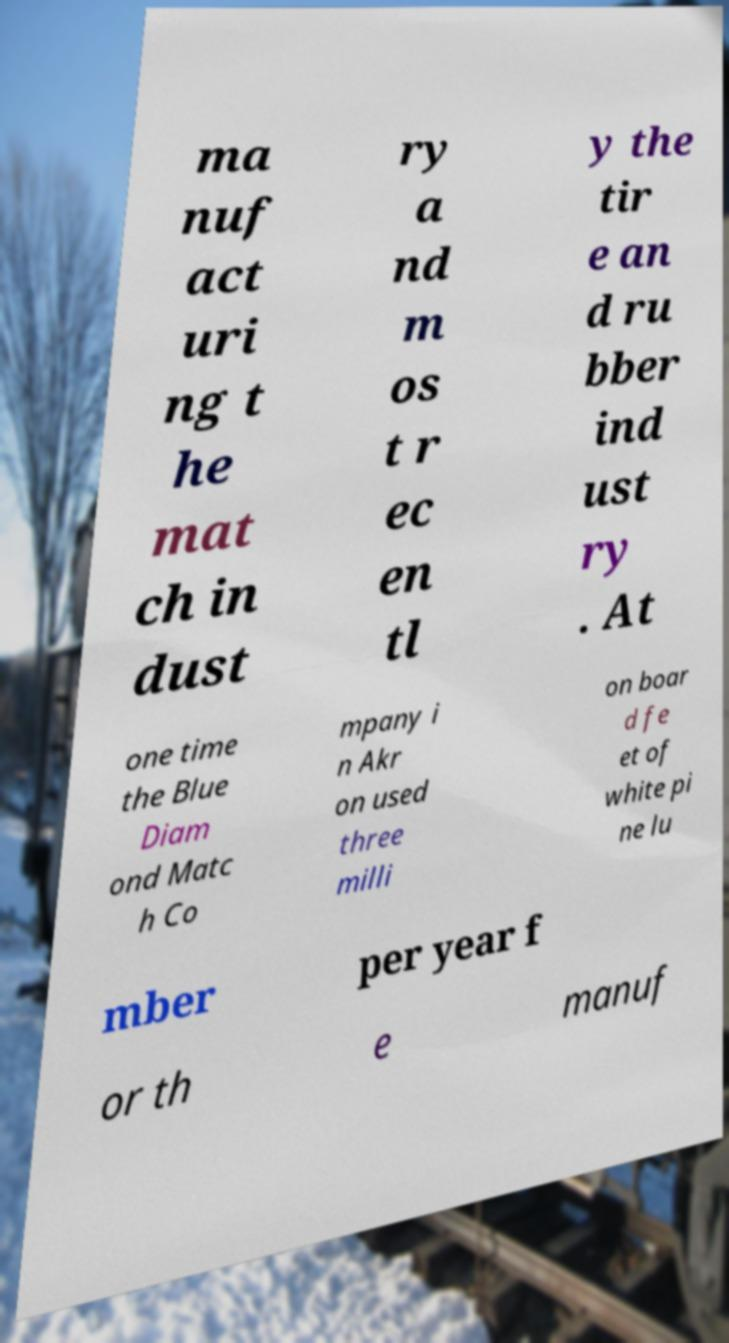I need the written content from this picture converted into text. Can you do that? ma nuf act uri ng t he mat ch in dust ry a nd m os t r ec en tl y the tir e an d ru bber ind ust ry . At one time the Blue Diam ond Matc h Co mpany i n Akr on used three milli on boar d fe et of white pi ne lu mber per year f or th e manuf 